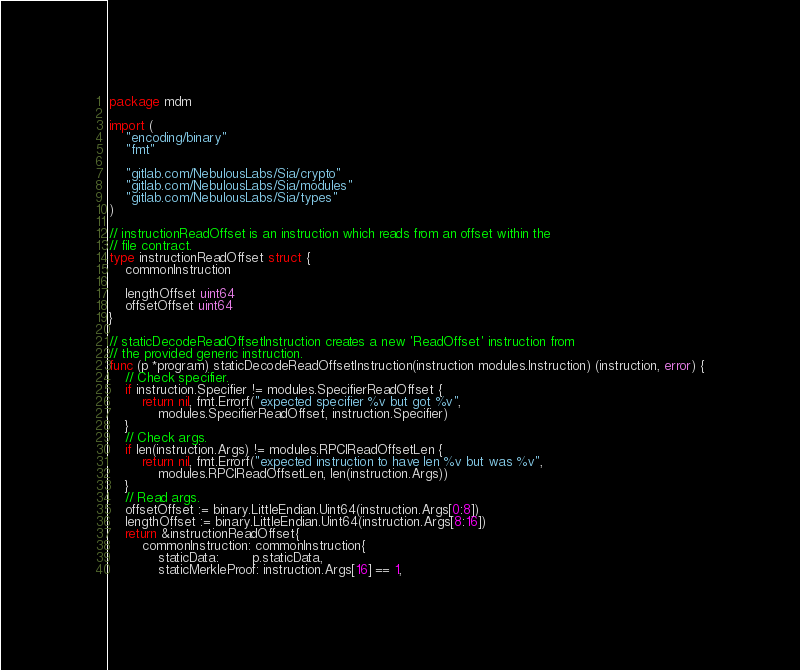Convert code to text. <code><loc_0><loc_0><loc_500><loc_500><_Go_>package mdm

import (
	"encoding/binary"
	"fmt"

	"gitlab.com/NebulousLabs/Sia/crypto"
	"gitlab.com/NebulousLabs/Sia/modules"
	"gitlab.com/NebulousLabs/Sia/types"
)

// instructionReadOffset is an instruction which reads from an offset within the
// file contract.
type instructionReadOffset struct {
	commonInstruction

	lengthOffset uint64
	offsetOffset uint64
}

// staticDecodeReadOffsetInstruction creates a new 'ReadOffset' instruction from
// the provided generic instruction.
func (p *program) staticDecodeReadOffsetInstruction(instruction modules.Instruction) (instruction, error) {
	// Check specifier.
	if instruction.Specifier != modules.SpecifierReadOffset {
		return nil, fmt.Errorf("expected specifier %v but got %v",
			modules.SpecifierReadOffset, instruction.Specifier)
	}
	// Check args.
	if len(instruction.Args) != modules.RPCIReadOffsetLen {
		return nil, fmt.Errorf("expected instruction to have len %v but was %v",
			modules.RPCIReadOffsetLen, len(instruction.Args))
	}
	// Read args.
	offsetOffset := binary.LittleEndian.Uint64(instruction.Args[0:8])
	lengthOffset := binary.LittleEndian.Uint64(instruction.Args[8:16])
	return &instructionReadOffset{
		commonInstruction: commonInstruction{
			staticData:        p.staticData,
			staticMerkleProof: instruction.Args[16] == 1,</code> 